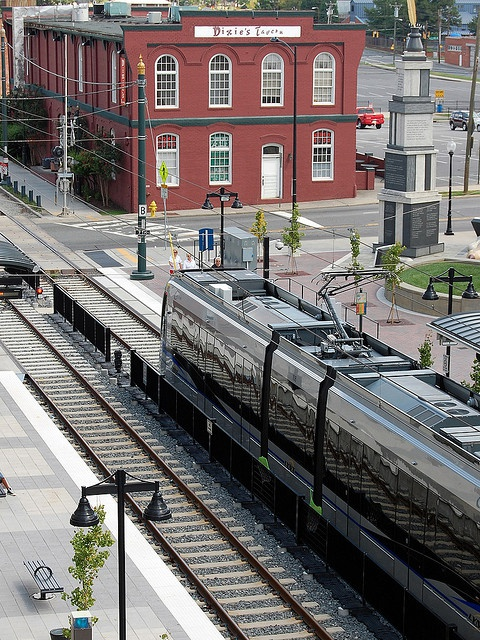Describe the objects in this image and their specific colors. I can see train in darkgray, black, gray, and lightgray tones, bench in darkgray, lightgray, black, and gray tones, truck in darkgray, black, salmon, brown, and lightgray tones, car in darkgray, gray, lightgray, and black tones, and people in darkgray, lavender, brown, tan, and lightpink tones in this image. 